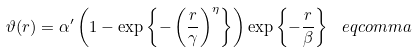Convert formula to latex. <formula><loc_0><loc_0><loc_500><loc_500>\vartheta ( r ) = \alpha ^ { \prime } \left ( 1 - \exp \left \{ - \left ( \frac { r } { \gamma } \right ) ^ { \eta } \right \} \right ) \exp \left \{ - \frac { r } { \beta } \right \} \ e q c o m m a</formula> 